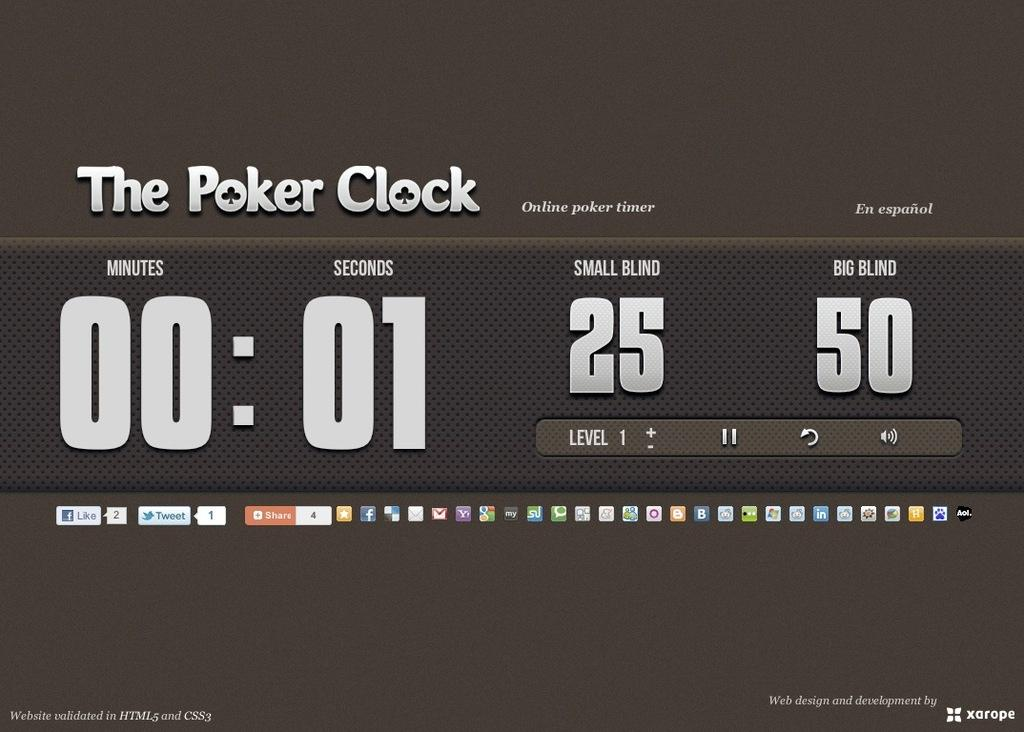<image>
Relay a brief, clear account of the picture shown. a screen with The Poker Clock written on it 